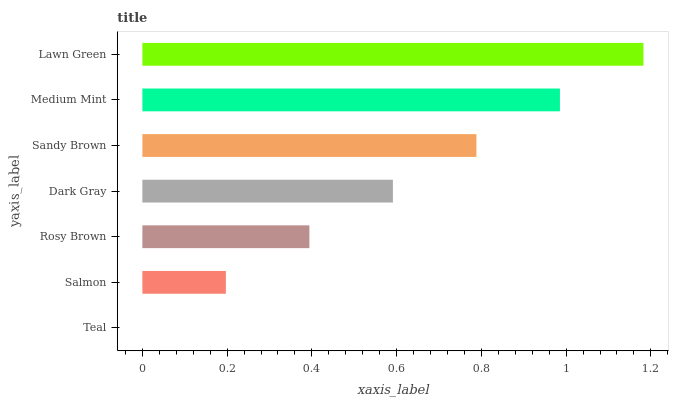Is Teal the minimum?
Answer yes or no. Yes. Is Lawn Green the maximum?
Answer yes or no. Yes. Is Salmon the minimum?
Answer yes or no. No. Is Salmon the maximum?
Answer yes or no. No. Is Salmon greater than Teal?
Answer yes or no. Yes. Is Teal less than Salmon?
Answer yes or no. Yes. Is Teal greater than Salmon?
Answer yes or no. No. Is Salmon less than Teal?
Answer yes or no. No. Is Dark Gray the high median?
Answer yes or no. Yes. Is Dark Gray the low median?
Answer yes or no. Yes. Is Lawn Green the high median?
Answer yes or no. No. Is Lawn Green the low median?
Answer yes or no. No. 